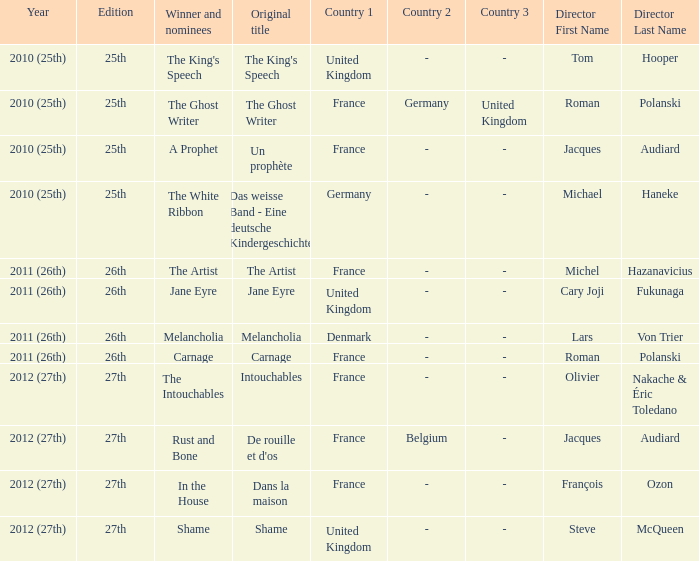What was the original title for the king's speech? The King's Speech. 